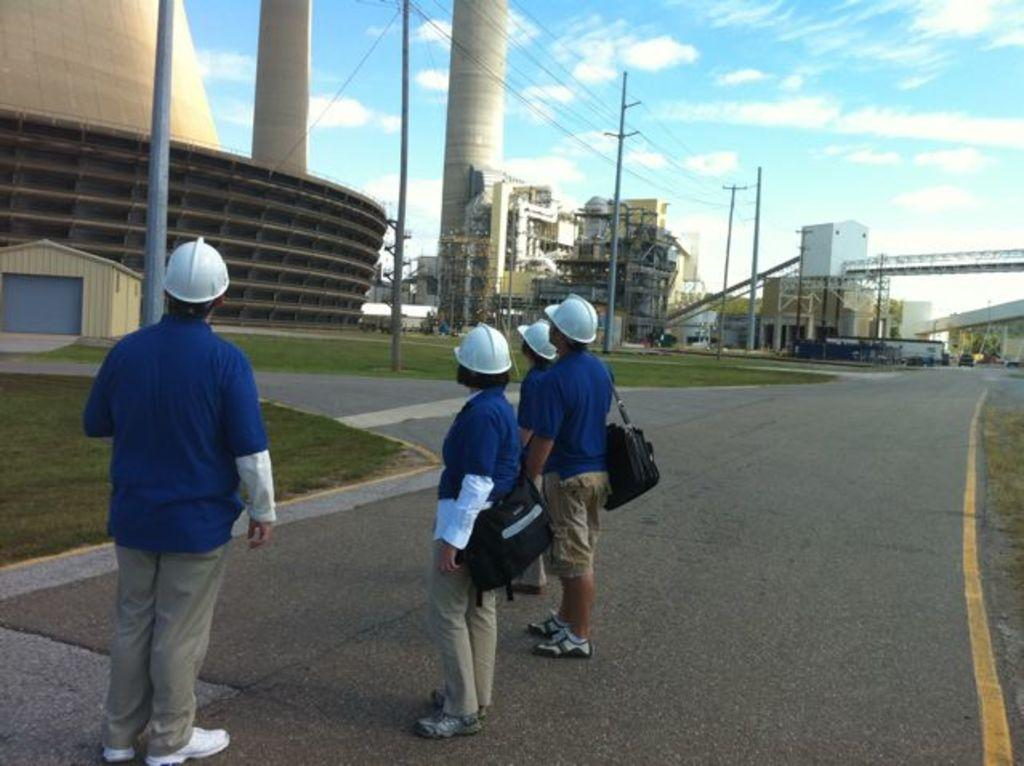How many people are on the road in the image? There are four persons on the road in the image. What type of vegetation can be seen in the image? There is grass visible in the image. What structures can be seen in the image? There are poles and buildings in the image. What else can be seen on the road in the image? There are vehicles in the image. What is visible in the background of the image? The sky is visible in the background of the image, and there are clouds in the sky. Can you tell me what shape the monkey is making in the image? There is no monkey present in the image, so it is not possible to determine the shape it might be making. What message of peace can be seen in the image? There is no message of peace depicted in the image. 